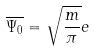Convert formula to latex. <formula><loc_0><loc_0><loc_500><loc_500>\overline { \Psi _ { 0 } } = \sqrt { \frac { m } { \pi } } e</formula> 